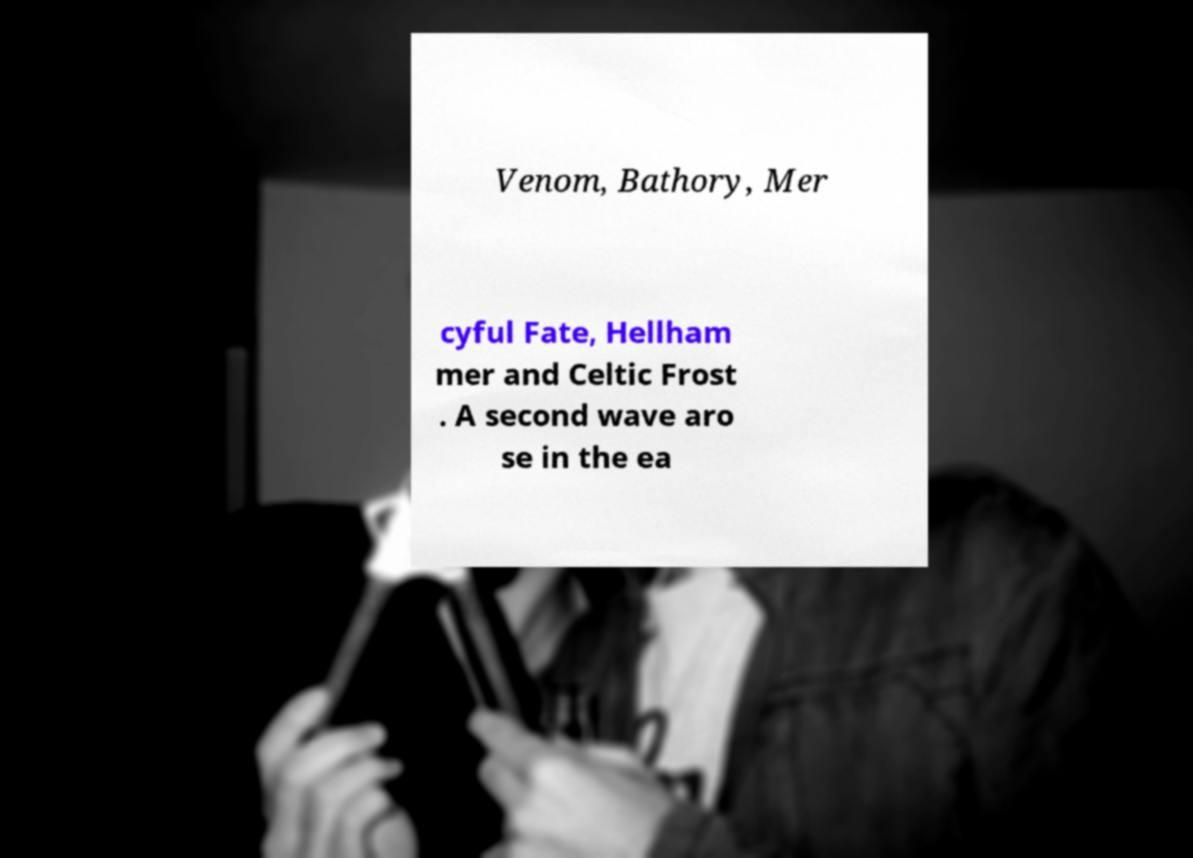Please identify and transcribe the text found in this image. Venom, Bathory, Mer cyful Fate, Hellham mer and Celtic Frost . A second wave aro se in the ea 